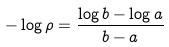<formula> <loc_0><loc_0><loc_500><loc_500>- \log \rho = \frac { \log b - \log a } { b - a }</formula> 